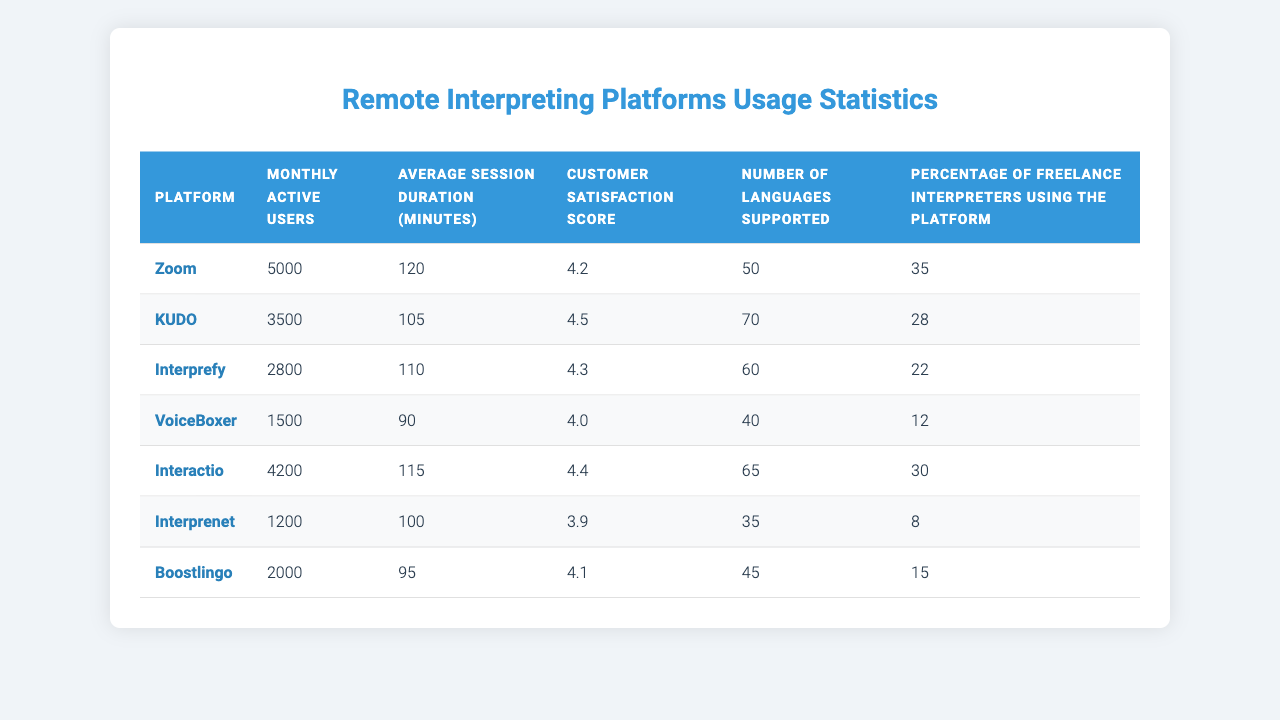What is the customer satisfaction score for KUDO? The table indicates the customer satisfaction score for KUDO under the relevant metric column. The score listed for KUDO is 4.5.
Answer: 4.5 Which platform has the highest number of monthly active users? By examining the "Monthly active users" column, we can see that Zoom has the highest number at 5000.
Answer: Zoom What is the average session duration for Interprefy? The average session duration for Interprefy can be found directly in the corresponding row under "Average session duration (minutes)", which is 110 minutes.
Answer: 110 What is the percentage of freelance interpreters using VoiceBoxer? VoiceBoxer's percentage of freelance interpreters is listed in the last column, which shows 12%.
Answer: 12% How many platforms support more than 60 languages? By reviewing the "Number of languages supported" column, we find that KUDO (70), Interprefy (60), and Interactio (65) support more than 60 languages, totaling three platforms.
Answer: 3 True or False: Interprenet has a higher average session duration than Zoom. The average session duration for Interprenet is 100 minutes, while for Zoom it is 120 minutes, so the statement is False.
Answer: False What is the difference in customer satisfaction scores between the highest and lowest platforms? We identify the highest score (KUDO with 4.5) and the lowest score (Interprenet with 3.9). The difference is calculated as 4.5 - 3.9 = 0.6.
Answer: 0.6 Which platform has the lowest percentage of freelance interpreters using it? By comparing the percentages, Interprenet has the lowest percentage at 8%.
Answer: Interprenet What is the average number of monthly active users across all platforms? Adding the monthly active users (5000 + 3500 + 2800 + 1500 + 4200 + 1200 + 2000 = 20700) and dividing by the number of platforms (7), we get an average of 20700 / 7 = 2957.14.
Answer: 2957.14 If we combine the average session duration of Zoom and Interactio, what is the total? Zoom has an average session duration of 120 minutes, and Interactio has 115 minutes, so the total is 120 + 115 = 235 minutes.
Answer: 235 